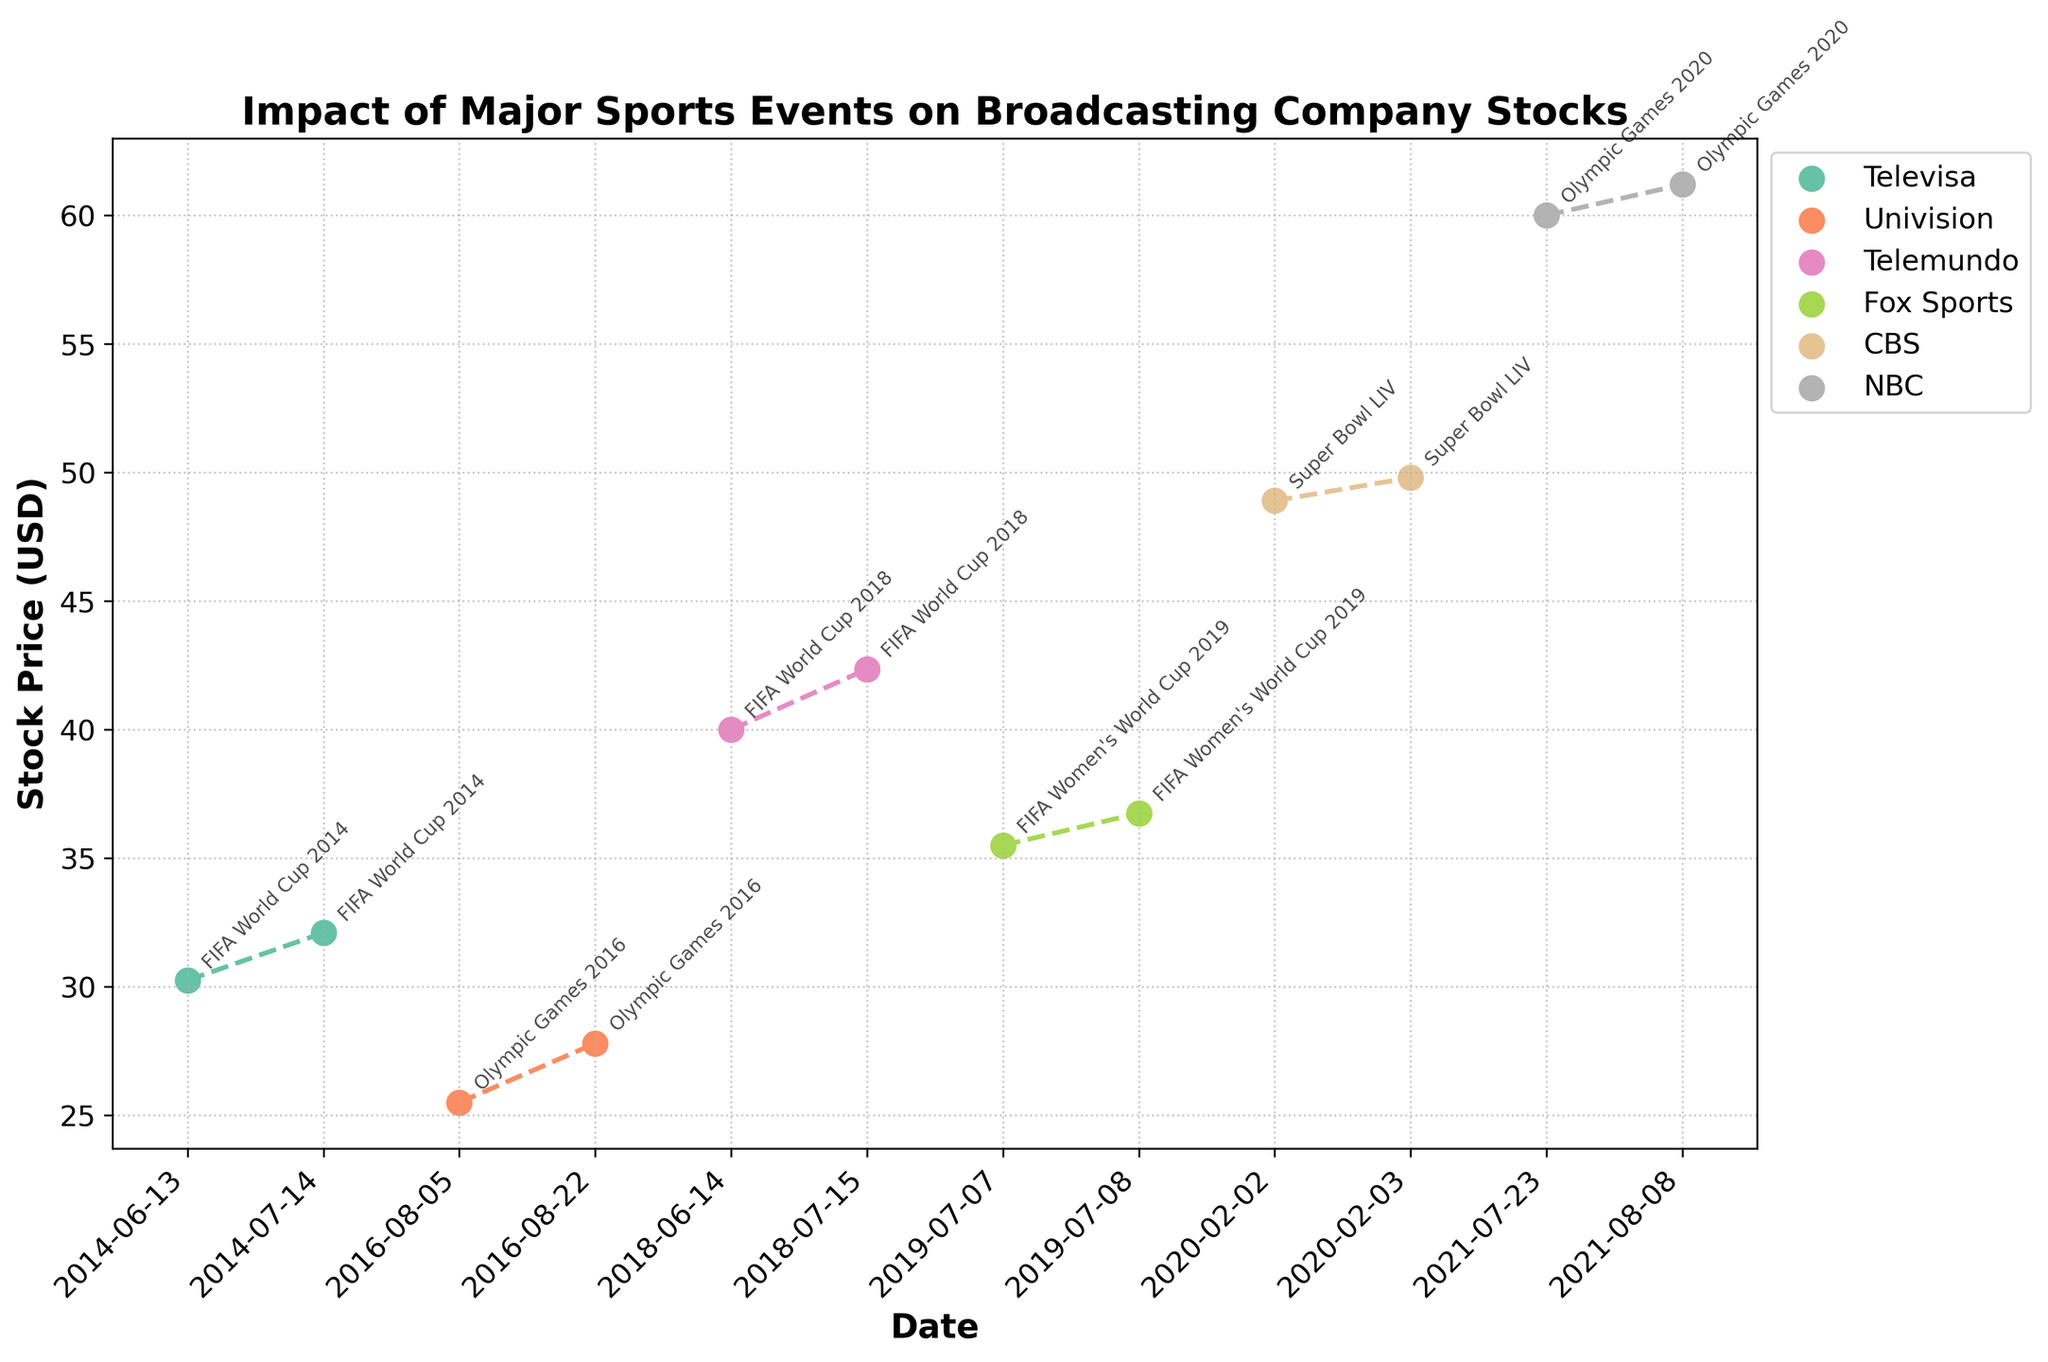Where is the peak stock price for Televisa during the FIFA World Cup 2014? The peak stock price for Televisa during the FIFA World Cup 2014 can be found by looking at the 'Televisa' line on the plot and identifying the highest value between the dates 2014-06-13 and 2014-07-14.
Answer: 32.10 How much did the stock price of Univision increase during the Olympic Games 2016? To find the increase, look at the stock prices of Univision on 2016-08-05 and 2016-08-22 and subtract the earlier value from the later value: 27.80 - 25.50 = 2.30.
Answer: 2.30 Which company had the highest stock price during the Olympic Games 2020? Look at the stock prices for all companies that participated in the Olympic Games 2020 event and find the highest value. NBC has a stock price of 61.20 on 2021-08-08.
Answer: NBC Did any company's stock price decrease immediately after the end of a sporting event? Compare the stock prices of companies the day after the event ended and see if there was a reduction. No company's stock price decreased immediately after the event ended.
Answer: No Which event saw the largest stock price increase for any company, and by how much? To determine this, calculate the difference in stock prices for each event and identify the largest one. NBC's stock price increased by 1.20 during the Olympic Games 2020.
Answer: Olympic Games 2020, 1.20 